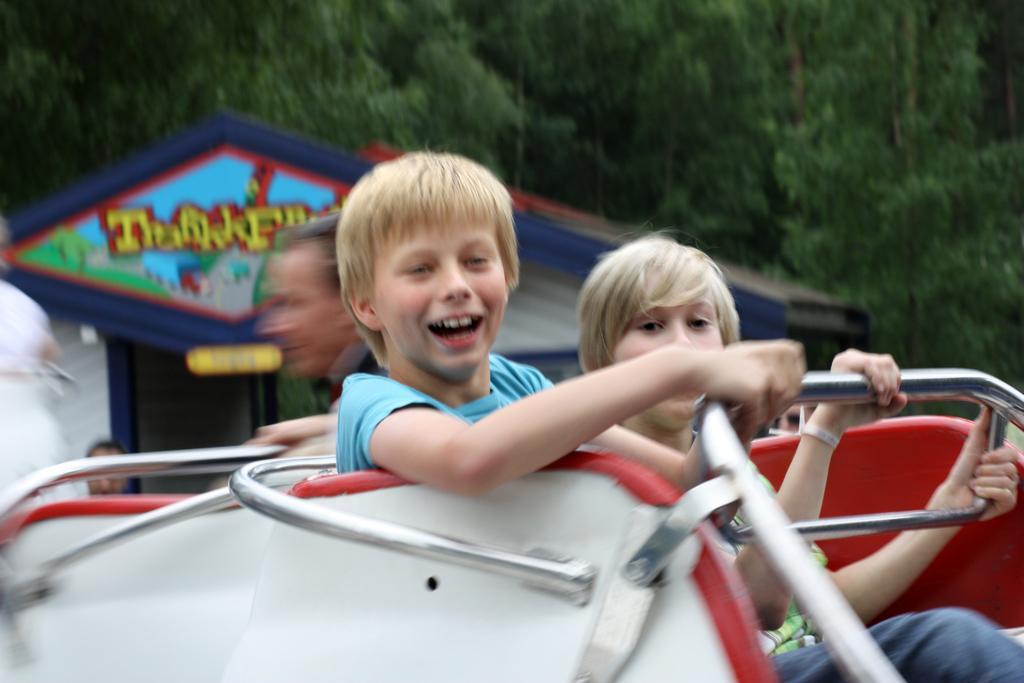Describe this image in one or two sentences. In this image we can see children sitting in a fun ride. In the background we can see persons, shed and trees. 